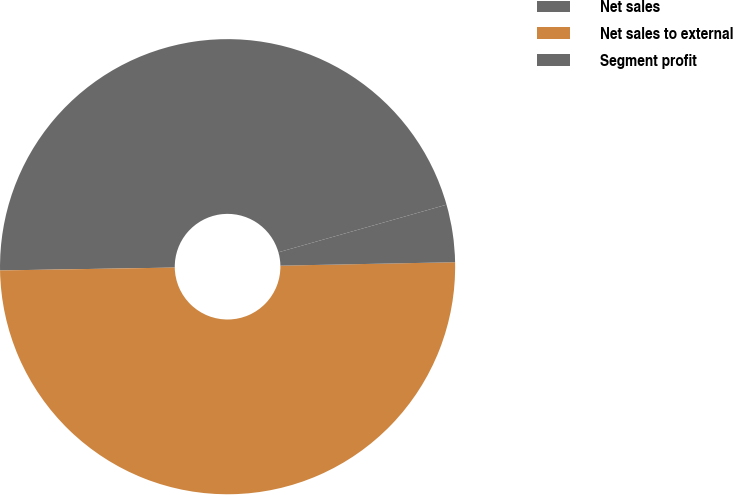Convert chart to OTSL. <chart><loc_0><loc_0><loc_500><loc_500><pie_chart><fcel>Net sales<fcel>Net sales to external<fcel>Segment profit<nl><fcel>45.87%<fcel>50.05%<fcel>4.08%<nl></chart> 